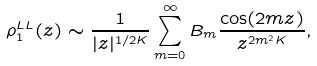Convert formula to latex. <formula><loc_0><loc_0><loc_500><loc_500>\rho _ { 1 } ^ { L L } ( z ) \sim \frac { 1 } { | z | ^ { 1 / 2 K } } \sum _ { m = 0 } ^ { \infty } B _ { m } \frac { \cos ( 2 m z ) } { z ^ { 2 m ^ { 2 } K } } ,</formula> 